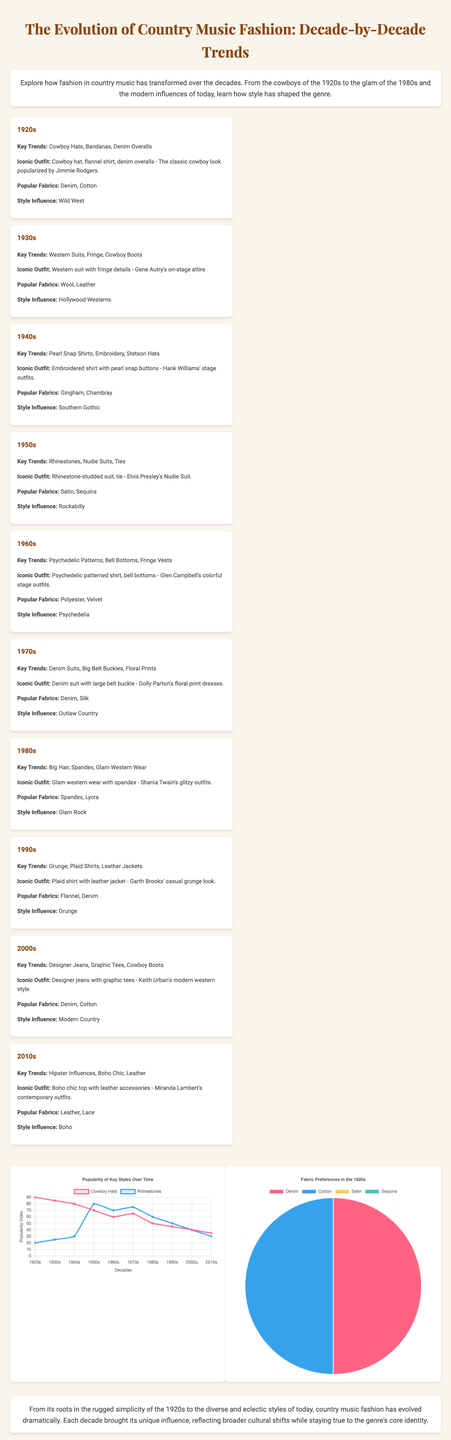What fabric was popular in the 1920s? The 1920s section lists denim and cotton as popular fabrics.
Answer: Denim, Cotton Which decade features rhinestone-studded suits? The 1950s section specifically mentions rhinestone-studded suits, associated with Elvis Presley.
Answer: 1950s What was an iconic outfit from the 1970s? The 1970s section describes a denim suit with a large belt buckle as an iconic outfit.
Answer: Denim suit with large belt buckle Which decade had the least popularity for cowboy hats? The line chart shows that the popularity of cowboy hats decreased most in the 2010s.
Answer: 2010s What is the percentage of satin used in the fabric preferences of the 1920s? The pie chart shows that satin's data is represented as 0 percent in the 1920s fabric preferences.
Answer: 0 Which decade is influenced by rockabilly? The 1950s section mentions rockabilly as the style influence during that decade.
Answer: 1950s What style influence characterized the 1980s? The 1980s section states glam rock as the style influence of that decade.
Answer: Glam Rock What is the main trend in the 2000s fashion? The 2000s section describes designer jeans as a key trend in that decade.
Answer: Designer Jeans In which decade did floral prints become popular? The 1970s section specifically mentions floral prints as a key trend.
Answer: 1970s 